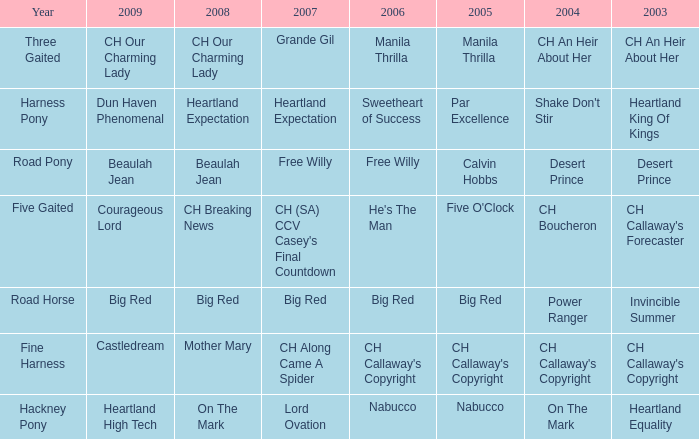What is the 2007 with ch callaway's copyright in 2003? CH Along Came A Spider. 